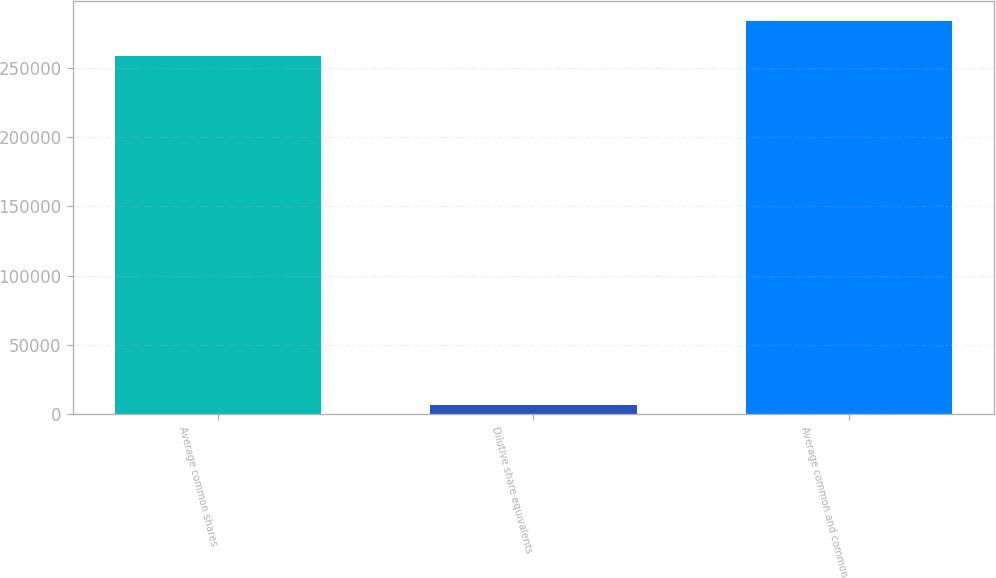Convert chart. <chart><loc_0><loc_0><loc_500><loc_500><bar_chart><fcel>Average common shares<fcel>Dilutive share equivalents<fcel>Average common and common<nl><fcel>258354<fcel>6267<fcel>284189<nl></chart> 